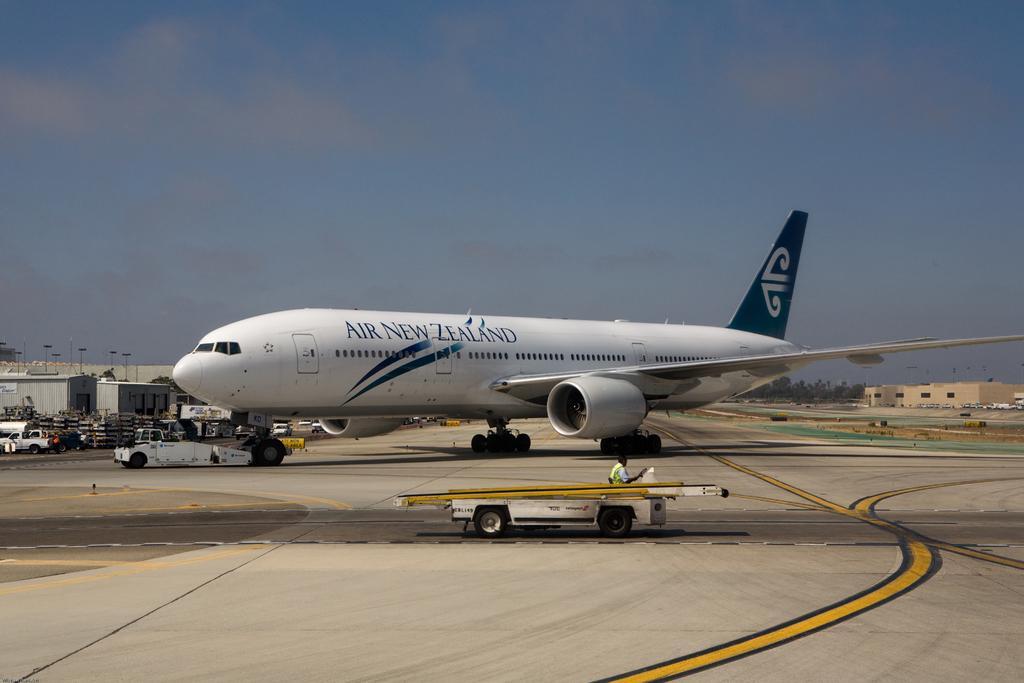Can you describe this image briefly? In the middle it is an aeroplane which is in white color and this is a run way in the down side of an image. 